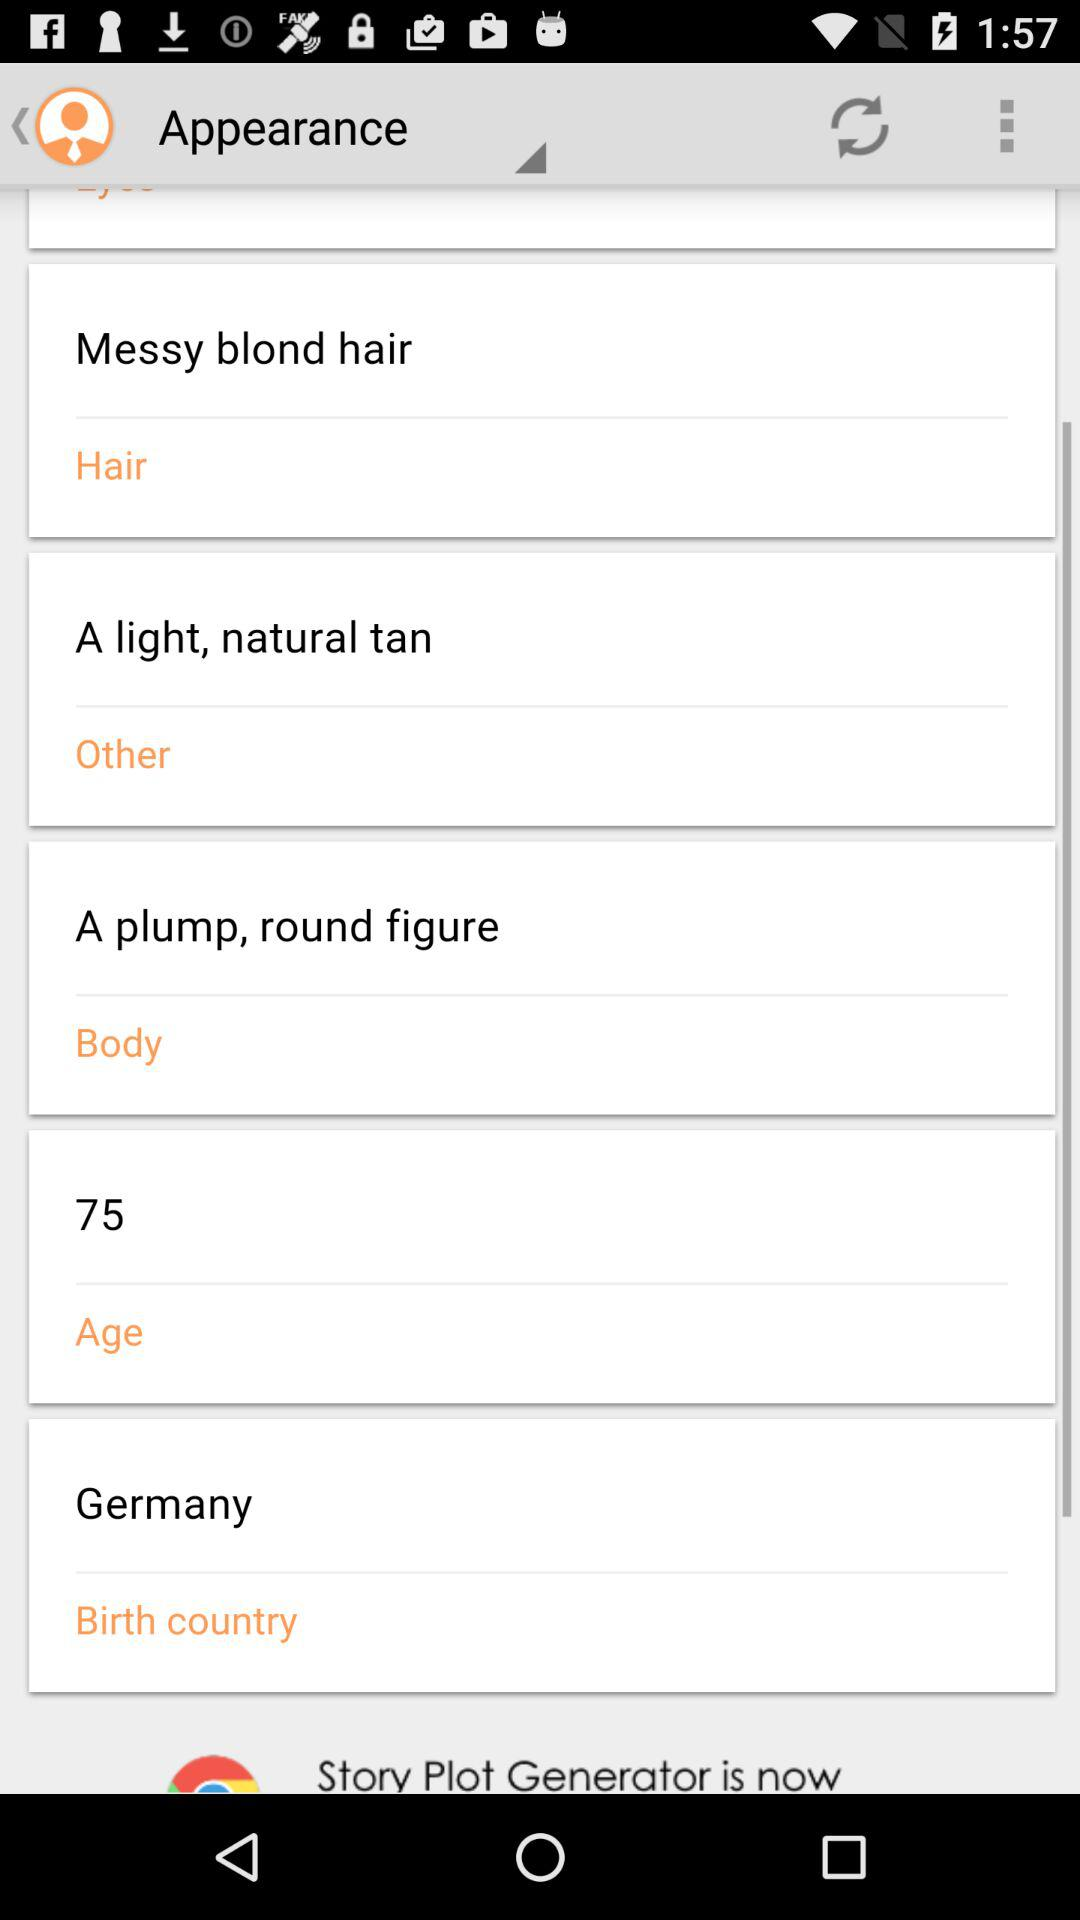What is the body type? The body type is a plump, round figure. 